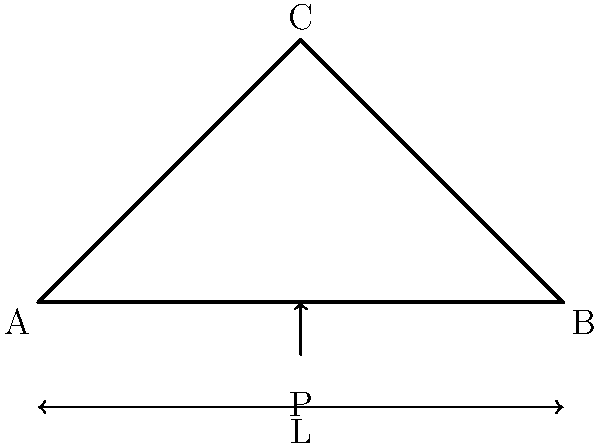For the simple truss bridge shown, with a span length L and a point load P at the center, what is the magnitude of the reaction force at support A? Assume the truss is symmetrical and statically determinate. To find the reaction force at support A, we'll follow these steps:

1. Recognize that this is a statically determinate structure, so we can use equilibrium equations.

2. Due to symmetry, we know that the reaction forces at A and B will be equal.

3. Let's call the reaction force at A as $R_A$.

4. Sum of vertical forces must equal zero:
   $$R_A + R_B - P = 0$$

5. Since $R_A = R_B$ due to symmetry:
   $$2R_A - P = 0$$

6. Solve for $R_A$:
   $$R_A = \frac{P}{2}$$

Therefore, the magnitude of the reaction force at support A is half of the applied load P.
Answer: $\frac{P}{2}$ 